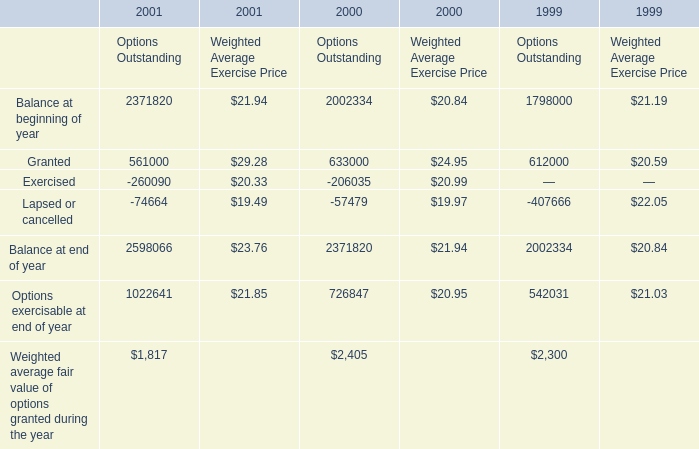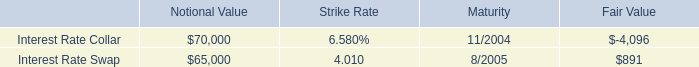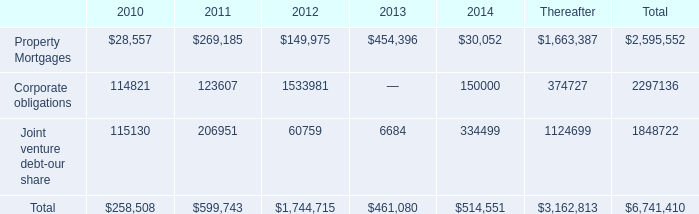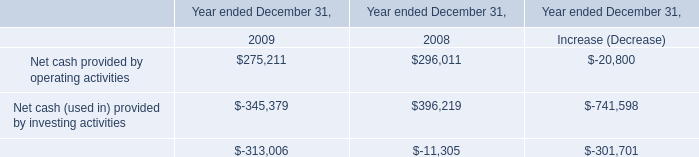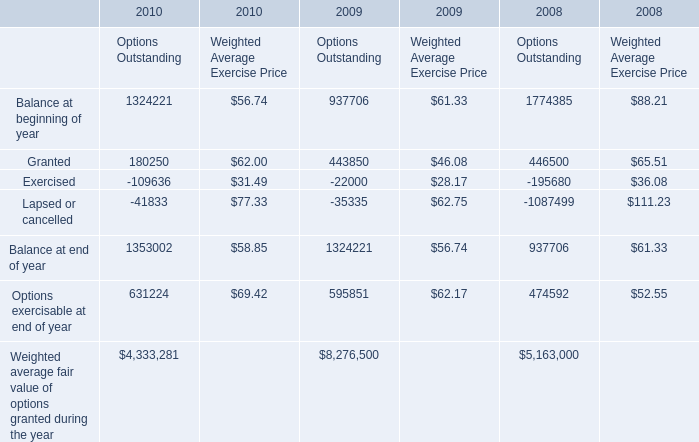What is the total amount of Corporate obligations of 2014, Granted of 1999 Options Outstanding, and Granted of 2000 Options Outstanding ? 
Computations: ((150000.0 + 612000.0) + 633000.0)
Answer: 1395000.0. 